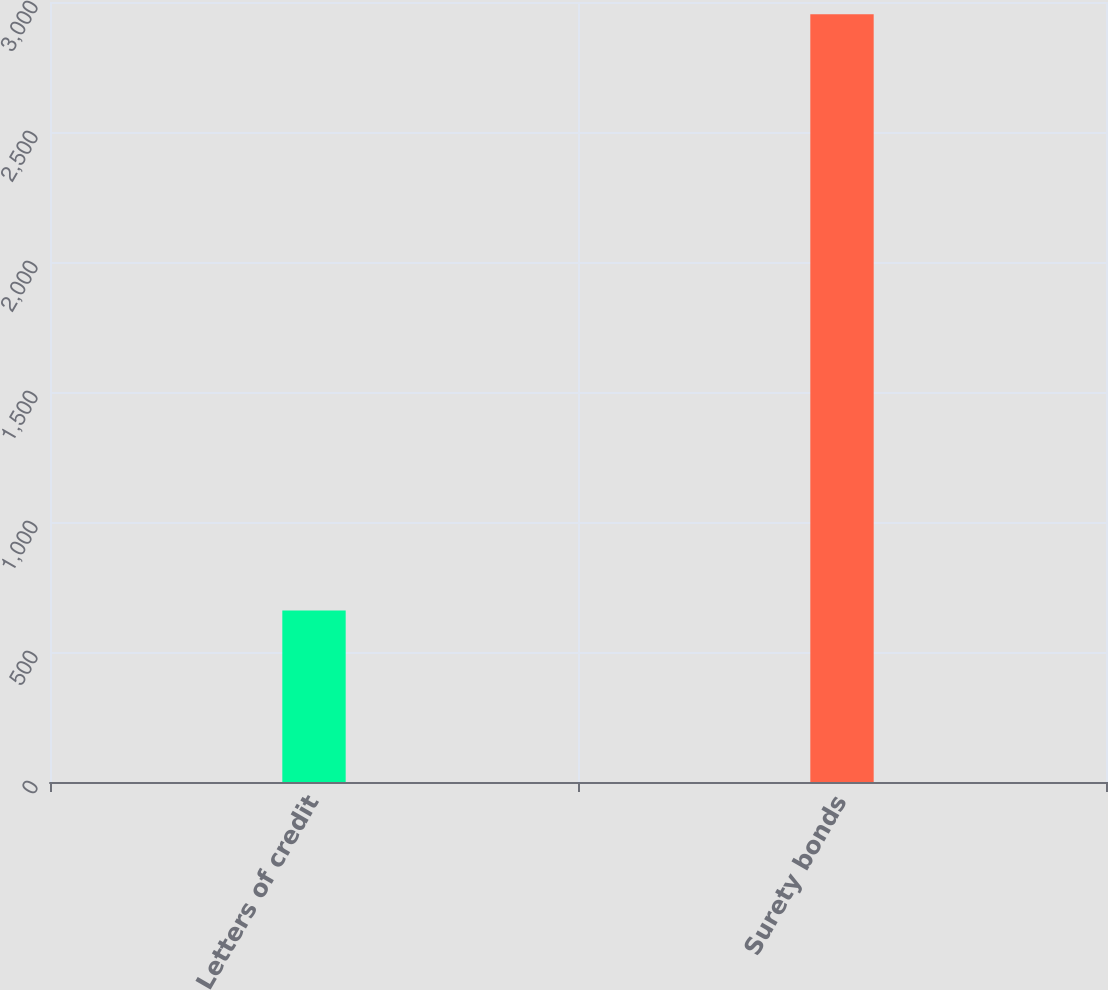Convert chart. <chart><loc_0><loc_0><loc_500><loc_500><bar_chart><fcel>Letters of credit<fcel>Surety bonds<nl><fcel>659.9<fcel>2952.7<nl></chart> 